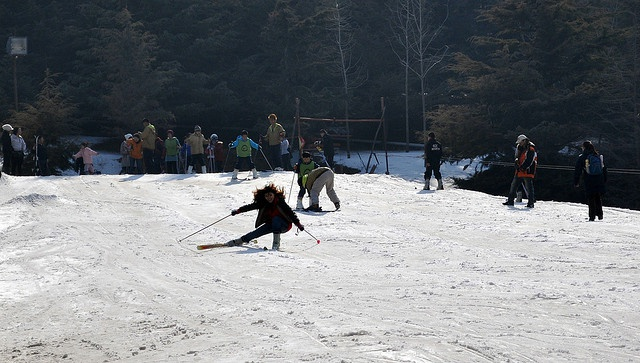Describe the objects in this image and their specific colors. I can see people in black, gray, and darkblue tones, people in black, gray, lightgray, and maroon tones, people in black, gray, darkgray, and white tones, people in black, maroon, gray, and darkgray tones, and people in black, gray, white, and darkgray tones in this image. 